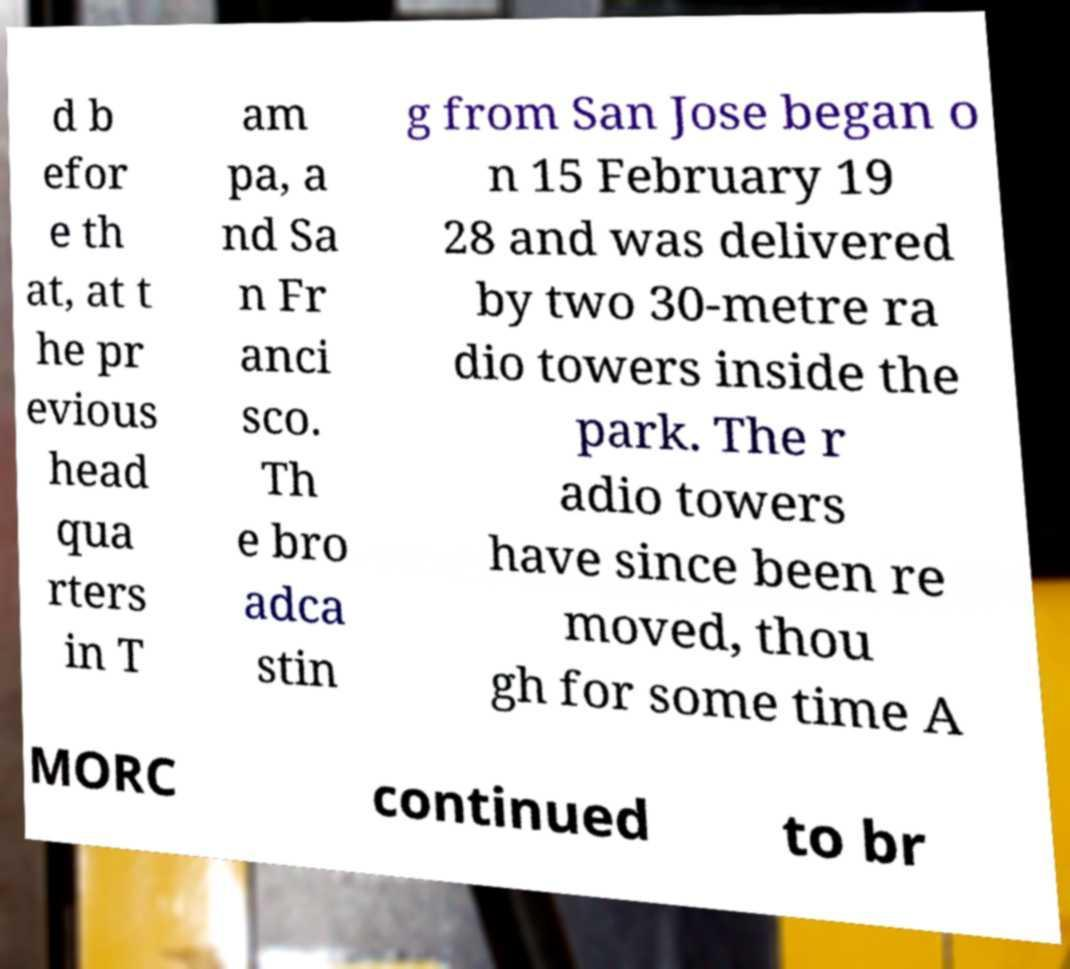Please read and relay the text visible in this image. What does it say? d b efor e th at, at t he pr evious head qua rters in T am pa, a nd Sa n Fr anci sco. Th e bro adca stin g from San Jose began o n 15 February 19 28 and was delivered by two 30-metre ra dio towers inside the park. The r adio towers have since been re moved, thou gh for some time A MORC continued to br 